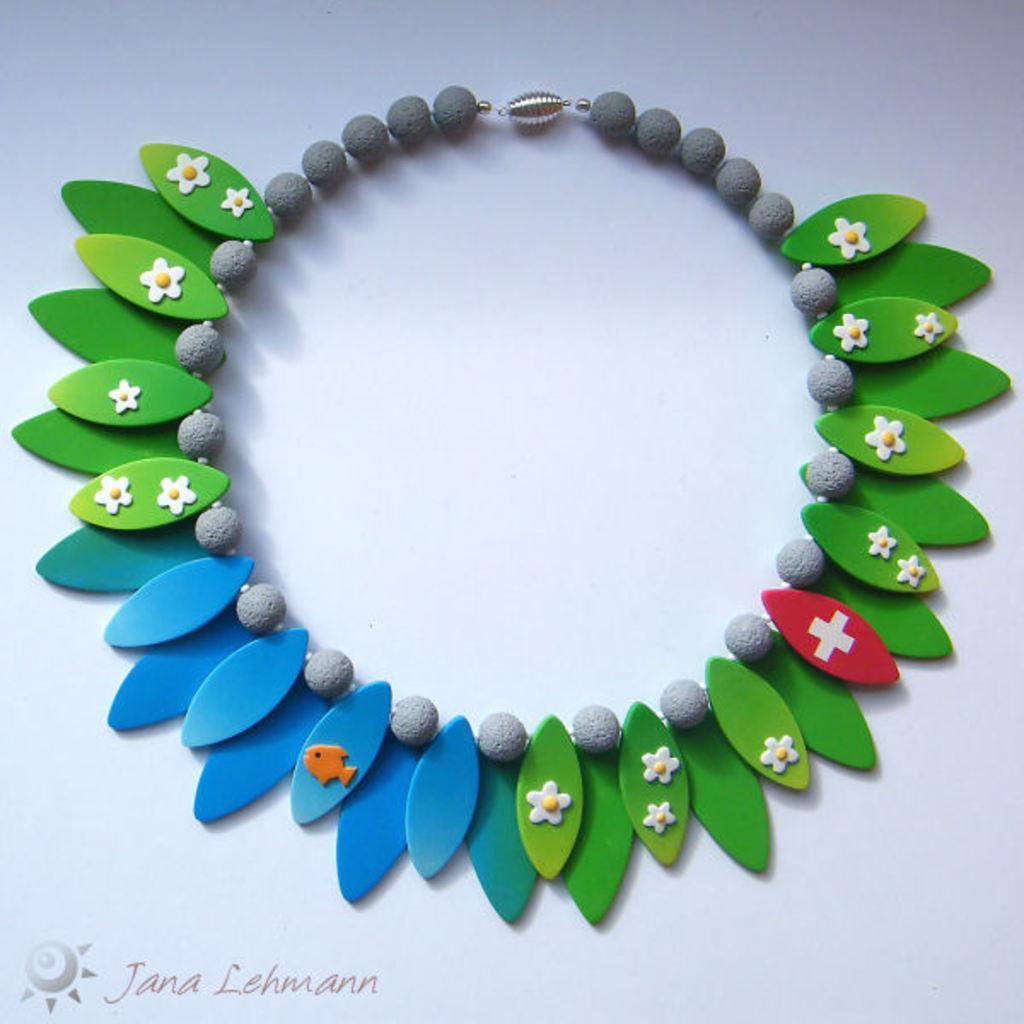Describe this image in one or two sentences. In this I can see the colorful jewellery on the grey color surface. The jewellery is in green, red, blue, orange and white color. 